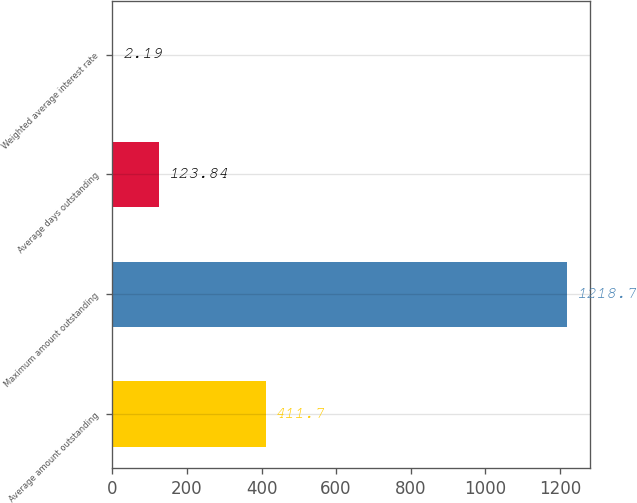Convert chart. <chart><loc_0><loc_0><loc_500><loc_500><bar_chart><fcel>Average amount outstanding<fcel>Maximum amount outstanding<fcel>Average days outstanding<fcel>Weighted average interest rate<nl><fcel>411.7<fcel>1218.7<fcel>123.84<fcel>2.19<nl></chart> 